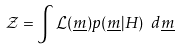Convert formula to latex. <formula><loc_0><loc_0><loc_500><loc_500>\mathcal { Z } = \int { \mathcal { L } ( \underline { m } ) p ( \underline { m } | H ) } \ d \underline { m }</formula> 